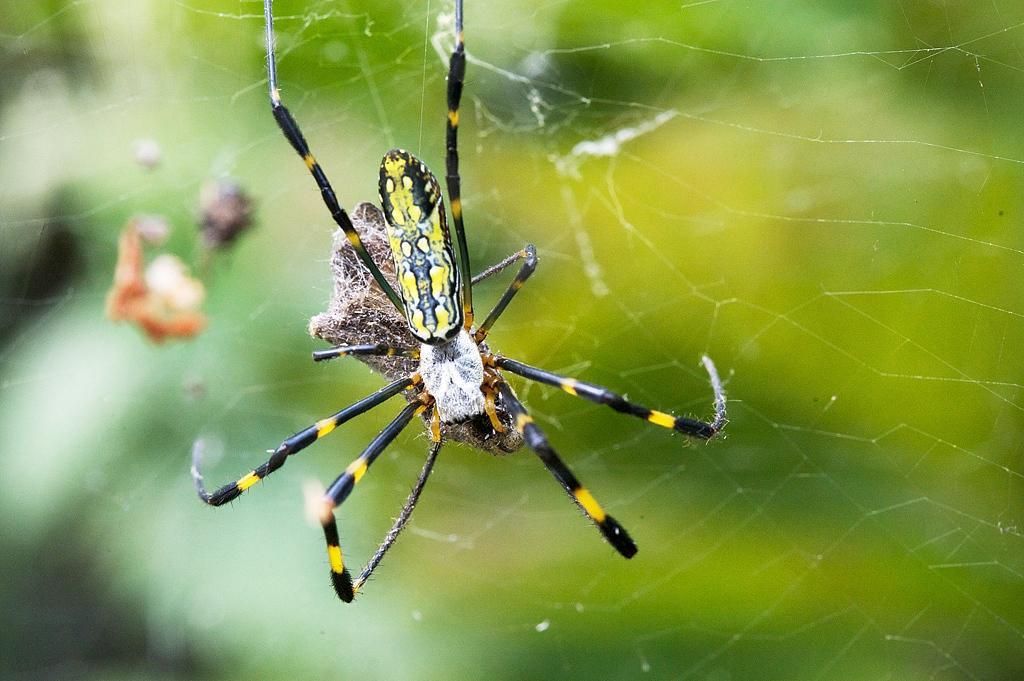In one or two sentences, can you explain what this image depicts? In this image we can see a spider. There is a spider web in the image. There is a blur background in the image. 